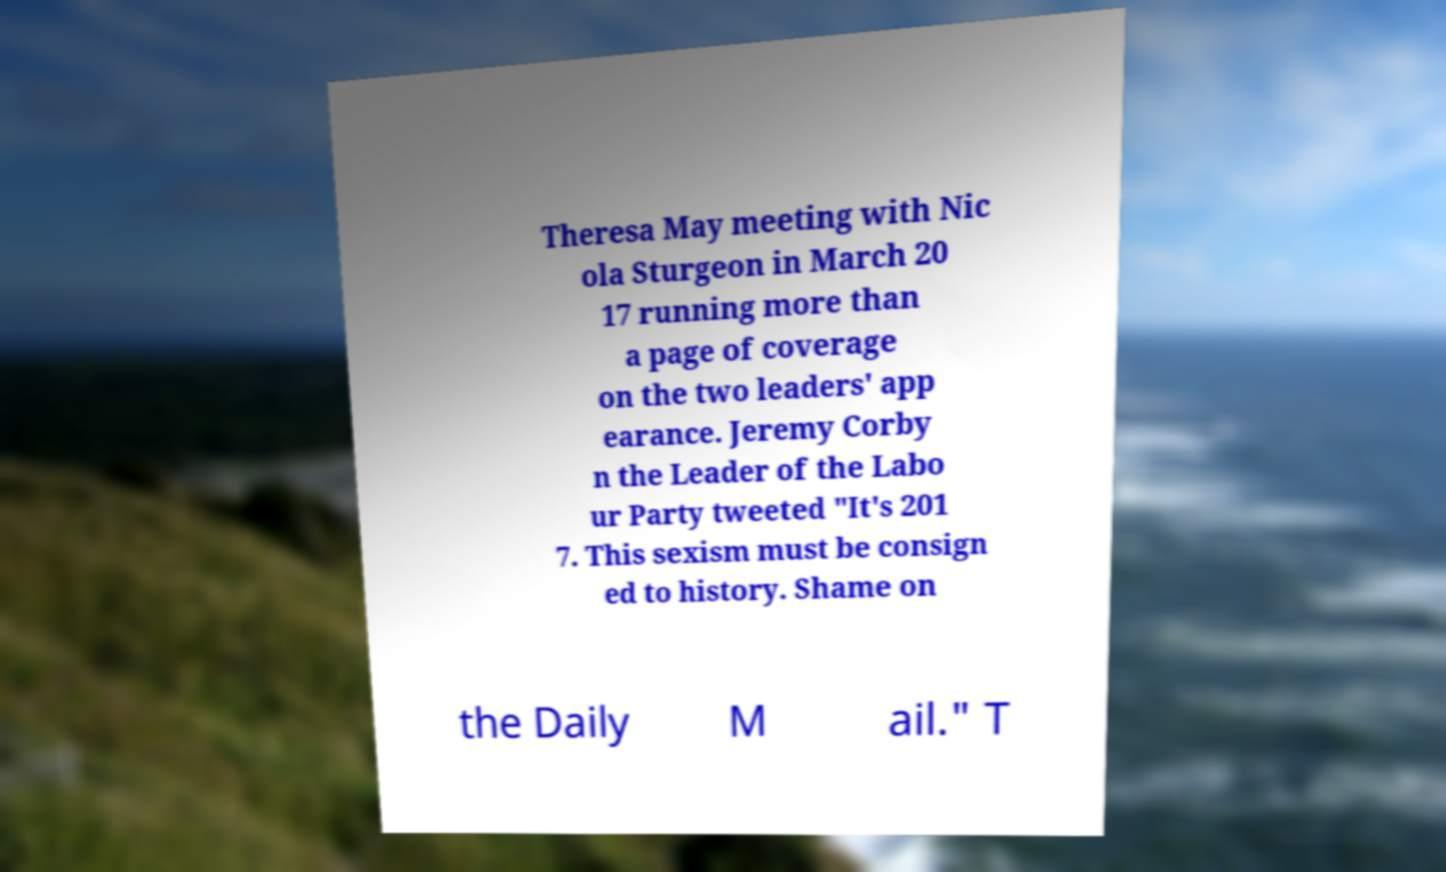What messages or text are displayed in this image? I need them in a readable, typed format. Theresa May meeting with Nic ola Sturgeon in March 20 17 running more than a page of coverage on the two leaders' app earance. Jeremy Corby n the Leader of the Labo ur Party tweeted "It's 201 7. This sexism must be consign ed to history. Shame on the Daily M ail." T 